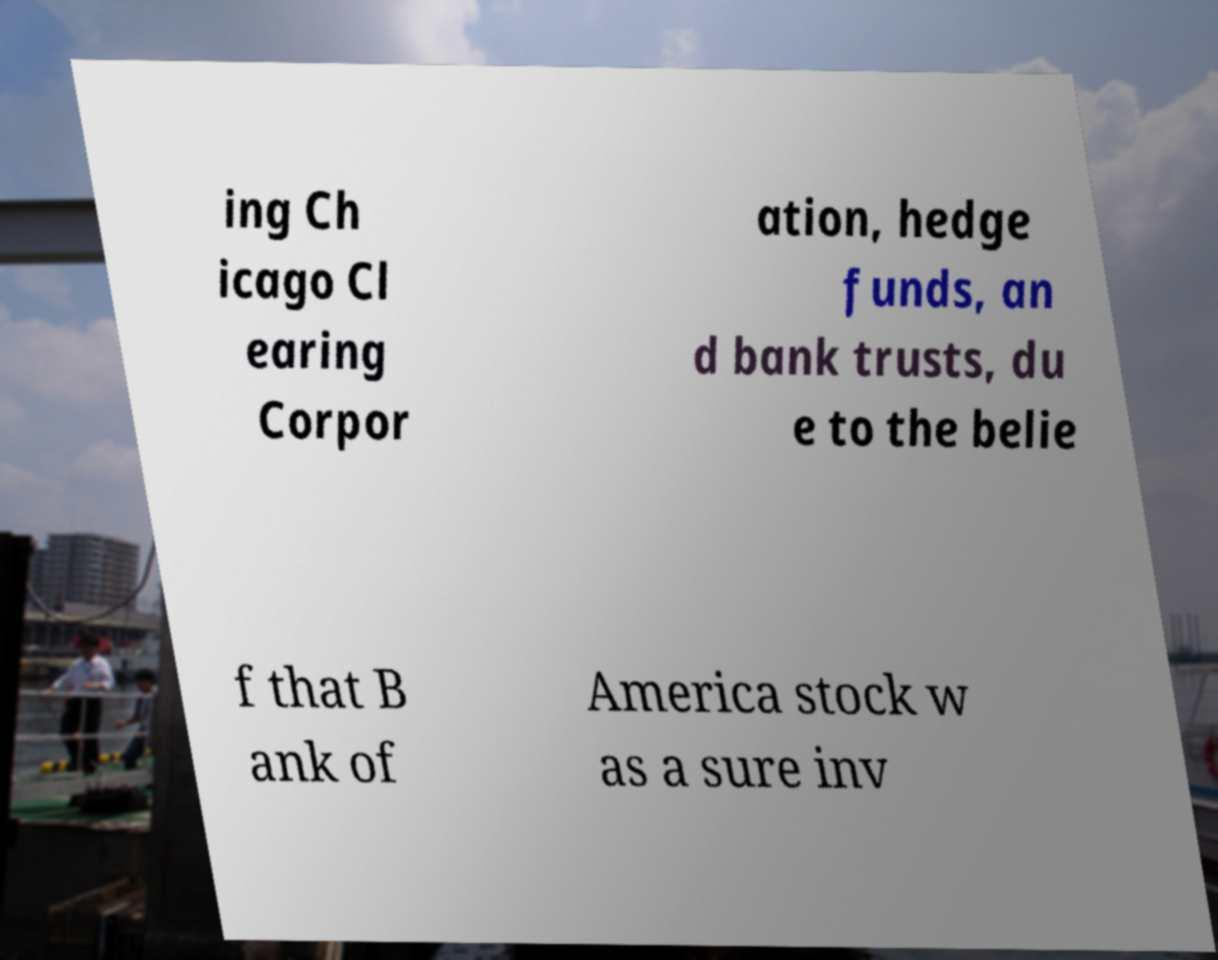Can you read and provide the text displayed in the image?This photo seems to have some interesting text. Can you extract and type it out for me? ing Ch icago Cl earing Corpor ation, hedge funds, an d bank trusts, du e to the belie f that B ank of America stock w as a sure inv 